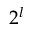<formula> <loc_0><loc_0><loc_500><loc_500>2 ^ { l }</formula> 